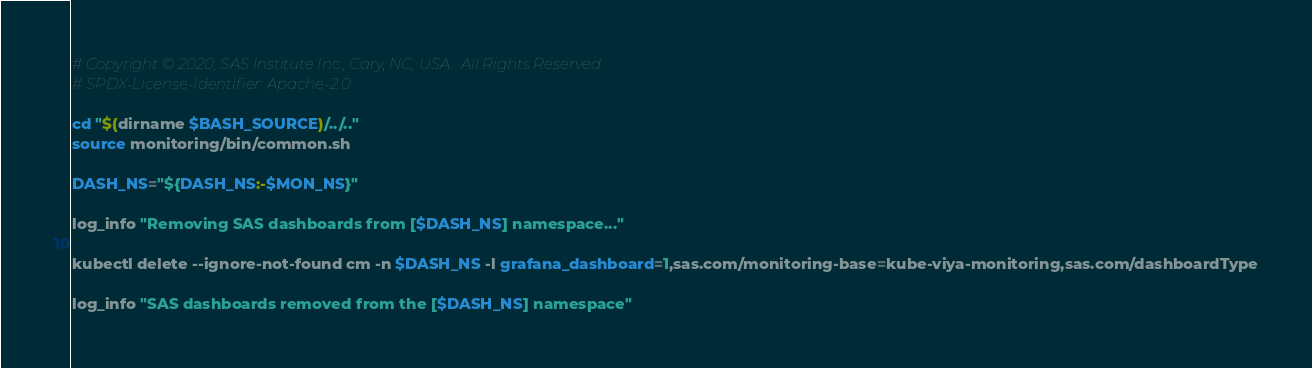<code> <loc_0><loc_0><loc_500><loc_500><_Bash_>
# Copyright © 2020, SAS Institute Inc., Cary, NC, USA.  All Rights Reserved.
# SPDX-License-Identifier: Apache-2.0

cd "$(dirname $BASH_SOURCE)/../.."
source monitoring/bin/common.sh

DASH_NS="${DASH_NS:-$MON_NS}"

log_info "Removing SAS dashboards from [$DASH_NS] namespace..."

kubectl delete --ignore-not-found cm -n $DASH_NS -l grafana_dashboard=1,sas.com/monitoring-base=kube-viya-monitoring,sas.com/dashboardType

log_info "SAS dashboards removed from the [$DASH_NS] namespace"
</code> 